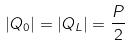Convert formula to latex. <formula><loc_0><loc_0><loc_500><loc_500>| Q _ { 0 } | = | Q _ { L } | = \frac { P } { 2 }</formula> 